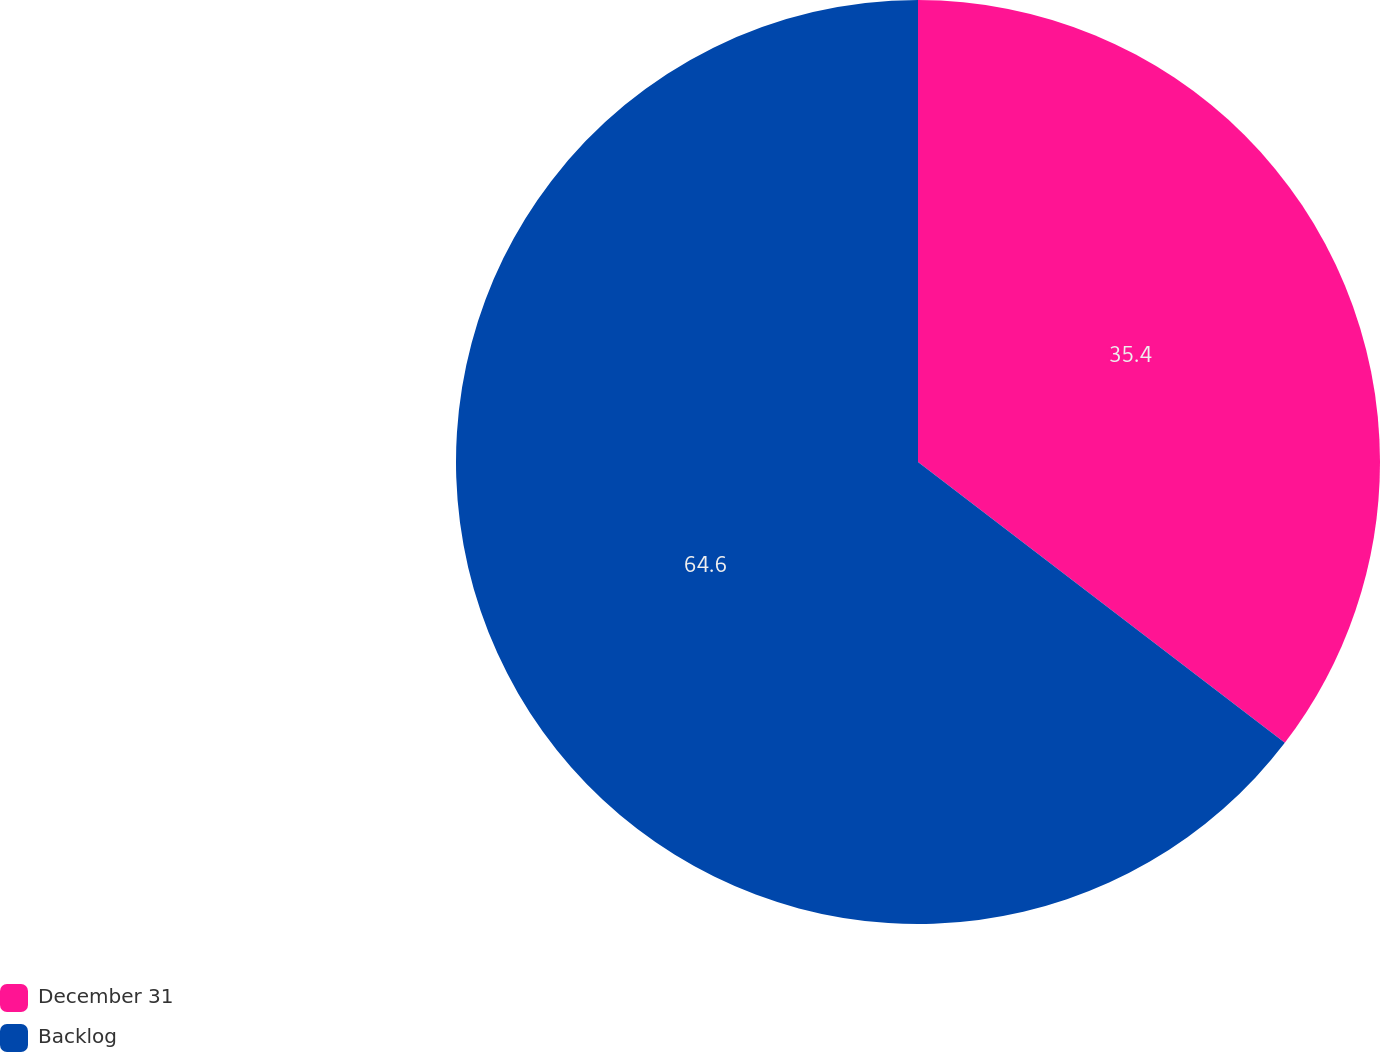Convert chart to OTSL. <chart><loc_0><loc_0><loc_500><loc_500><pie_chart><fcel>December 31<fcel>Backlog<nl><fcel>35.4%<fcel>64.6%<nl></chart> 